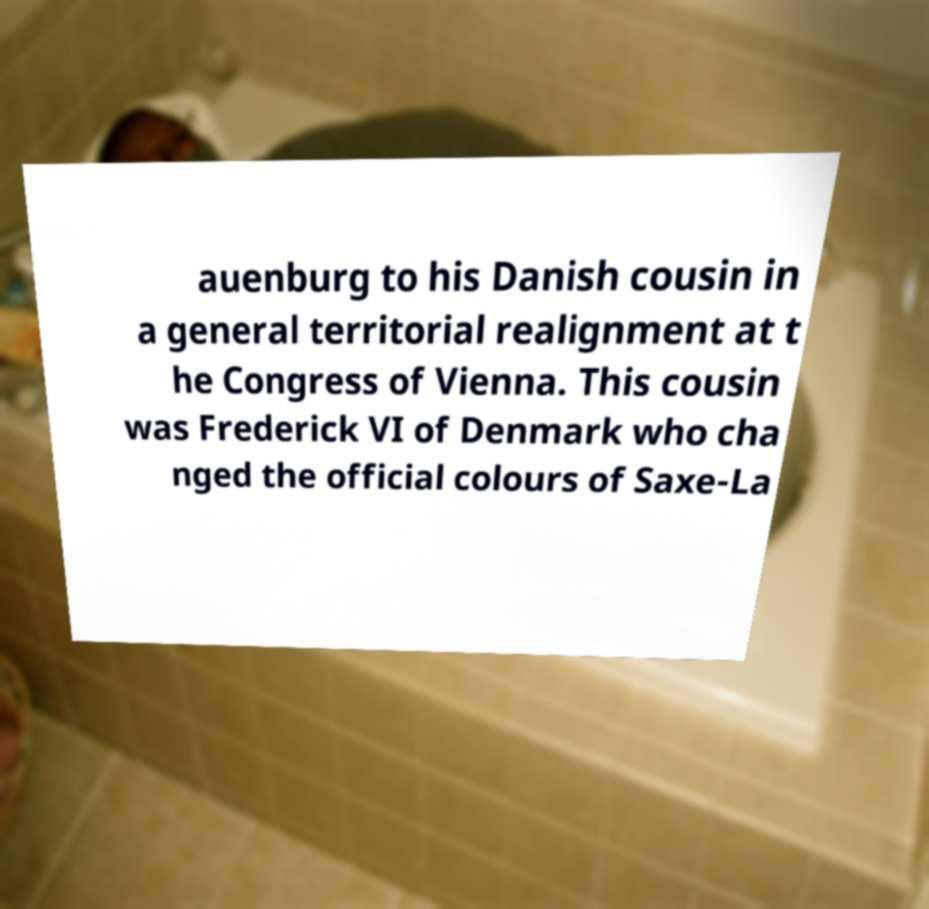Please identify and transcribe the text found in this image. auenburg to his Danish cousin in a general territorial realignment at t he Congress of Vienna. This cousin was Frederick VI of Denmark who cha nged the official colours of Saxe-La 